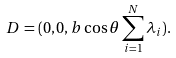Convert formula to latex. <formula><loc_0><loc_0><loc_500><loc_500>D = ( 0 , 0 , b \cos \theta \sum ^ { N } _ { i = 1 } \lambda _ { i } ) .</formula> 